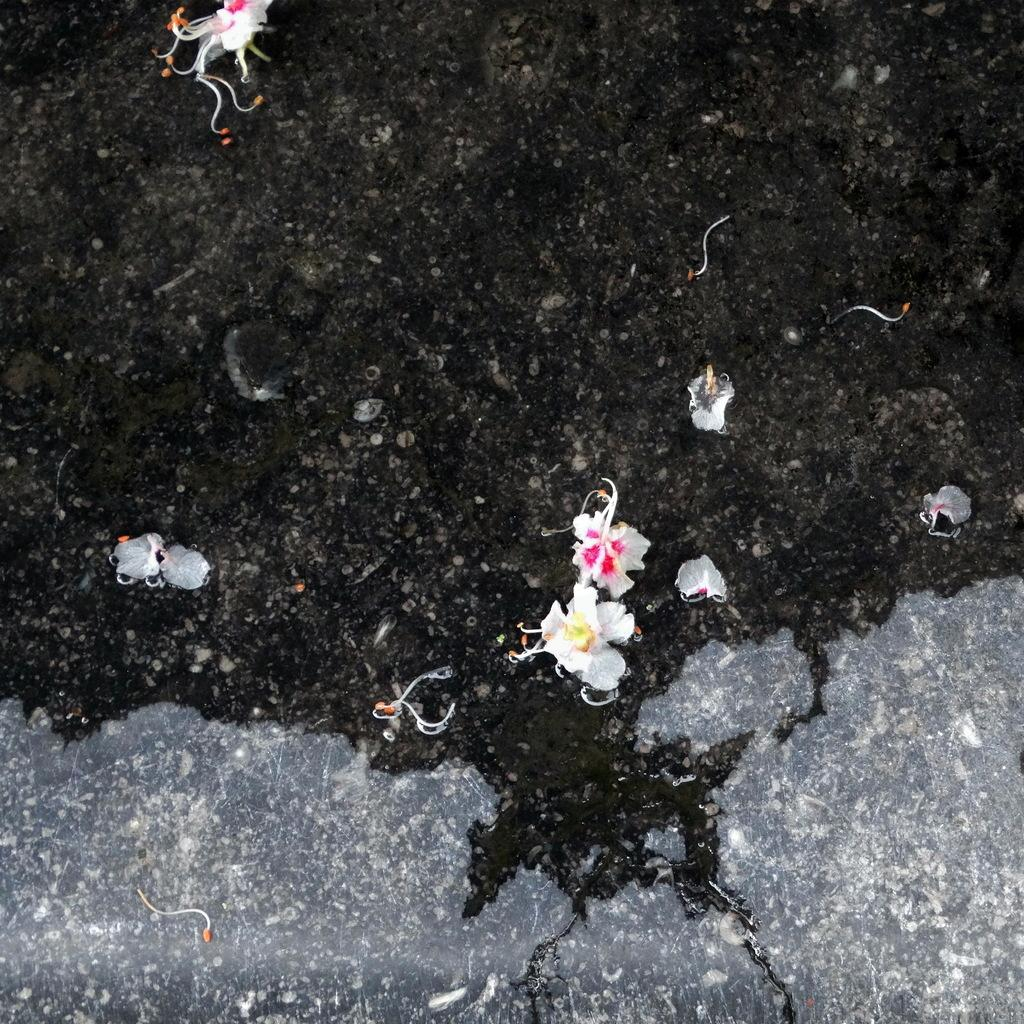What is present in the image that is liquid? There is water in the image. What type of plants can be seen in the image? There are flowers in the image. in the image. How many thumbs can be seen in the image? There are no thumbs visible in the image. Is the grandfather mentioned in the image? The image does not mention or depict a grandfather. 